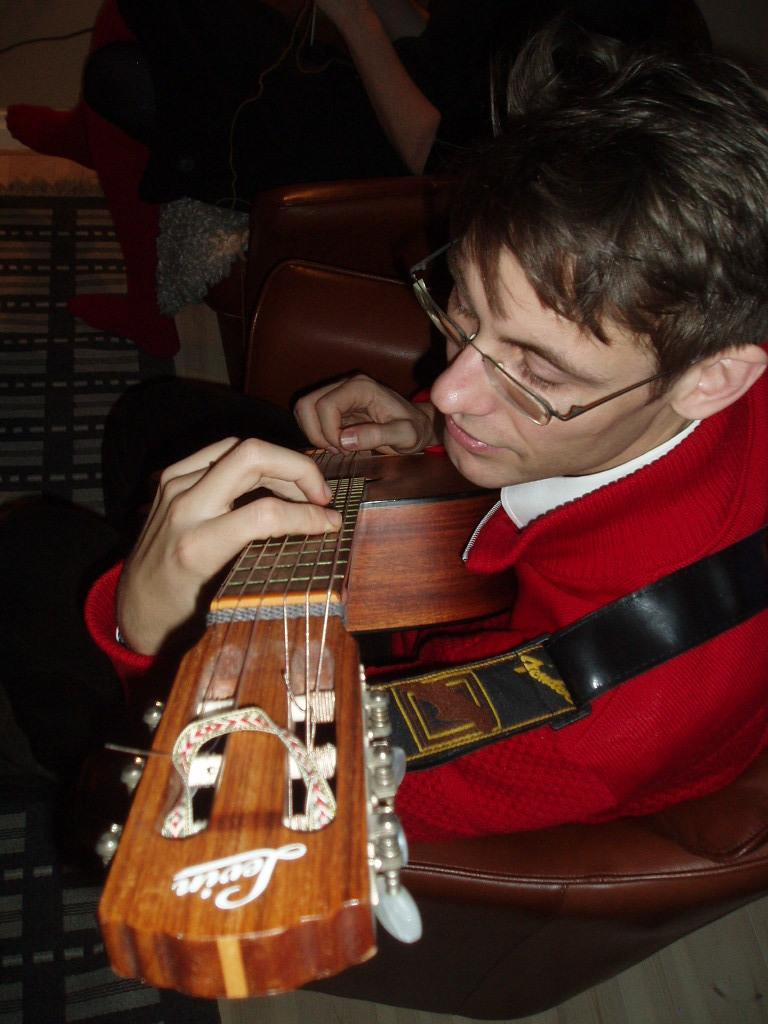What is the main subject in the foreground of the image? There is a person sitting in the foreground of the image. What is the person doing in the image? The person is playing a guitar. What type of furniture is the person sitting on? The person is sitting on a sofa. Can you describe the setting of the image? The image appears to be taken inside a room. How does the person fold the guitar in the image? The person is not folding the guitar in the image; they are playing it. 